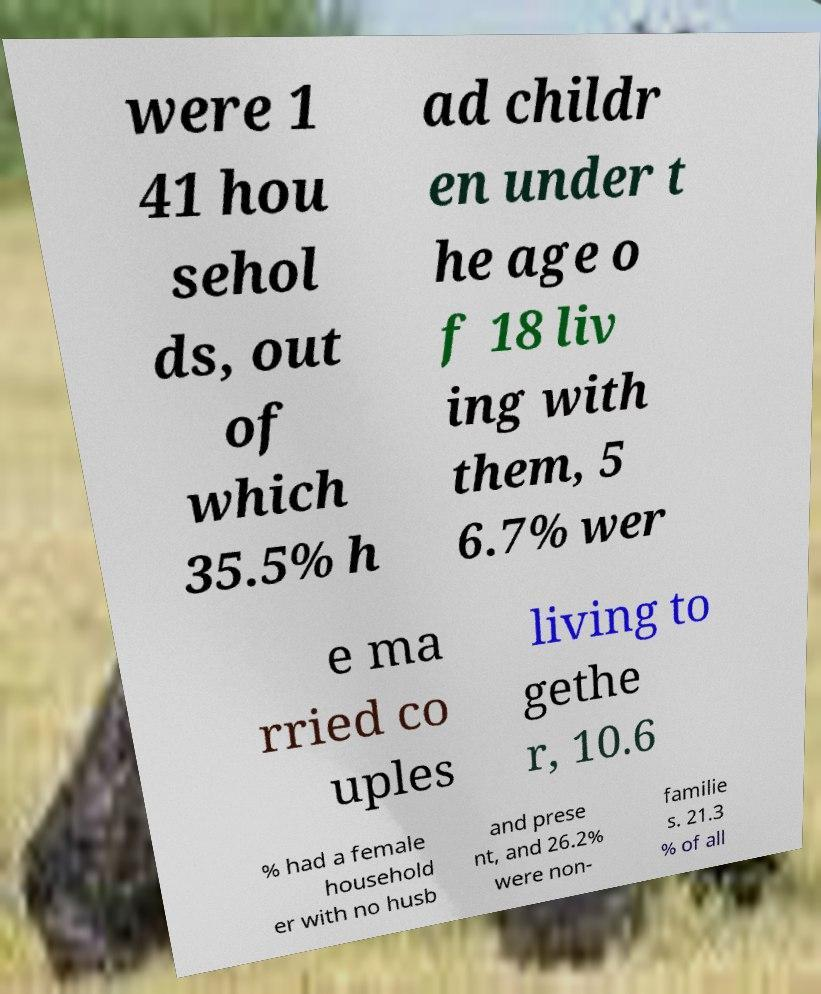For documentation purposes, I need the text within this image transcribed. Could you provide that? were 1 41 hou sehol ds, out of which 35.5% h ad childr en under t he age o f 18 liv ing with them, 5 6.7% wer e ma rried co uples living to gethe r, 10.6 % had a female household er with no husb and prese nt, and 26.2% were non- familie s. 21.3 % of all 